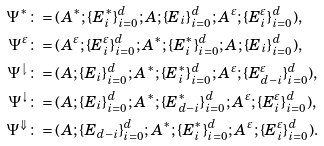Convert formula to latex. <formula><loc_0><loc_0><loc_500><loc_500>\Psi ^ { * } & \colon = ( A ^ { * } ; \{ E _ { i } ^ { * } \} _ { i = 0 } ^ { d } ; A ; \{ E _ { i } \} _ { i = 0 } ^ { d } ; A ^ { \varepsilon } ; \{ E _ { i } ^ { \varepsilon } \} _ { i = 0 } ^ { d } ) , \\ \Psi ^ { \varepsilon } & \colon = ( A ^ { \varepsilon } ; \{ E _ { i } ^ { \varepsilon } \} _ { i = 0 } ^ { d } ; A ^ { * } ; \{ E _ { i } ^ { * } \} _ { i = 0 } ^ { d } ; A ; \{ E _ { i } \} _ { i = 0 } ^ { d } ) , \\ \Psi ^ { \downharpoonright } & \colon = ( A ; \{ E _ { i } \} _ { i = 0 } ^ { d } ; A ^ { * } ; \{ E _ { i } ^ { * } \} _ { i = 0 } ^ { d } ; A ^ { \varepsilon } ; \{ E _ { d - i } ^ { \varepsilon } \} _ { i = 0 } ^ { d } ) , \\ \Psi ^ { \downarrow } & \colon = ( A ; \{ E _ { i } \} _ { i = 0 } ^ { d } ; A ^ { * } ; \{ E _ { d - i } ^ { * } \} _ { i = 0 } ^ { d } ; A ^ { \varepsilon } ; \{ E _ { i } ^ { \varepsilon } \} _ { i = 0 } ^ { d } ) , \\ \Psi ^ { \Downarrow } & \colon = ( A ; \{ E _ { d - i } \} _ { i = 0 } ^ { d } ; A ^ { * } ; \{ E _ { i } ^ { * } \} _ { i = 0 } ^ { d } ; A ^ { \varepsilon } ; \{ E _ { i } ^ { \varepsilon } \} _ { i = 0 } ^ { d } ) .</formula> 